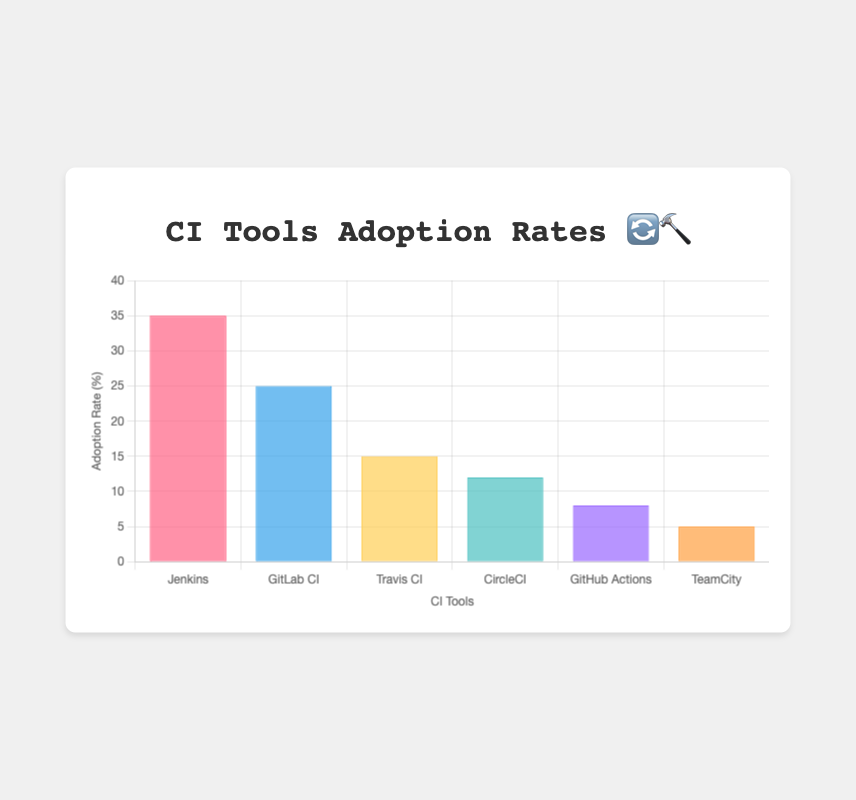What are the adoption rates for Jenkins and GitHub Actions? Jenkins has an adoption rate of 35% and GitHub Actions has an adoption rate of 8%. You can see this by looking at the height of the bars for these tools on the y-axis labeled "Adoption Rate (%)".
Answer: Jenkins: 35%, GitHub Actions: 8% What’s the title of the chart? The title is located at the top of the chart in bold text. It reads "CI Tools Adoption Rates 🔄🔨", which indicates that the chart visualizes the adoption rates of continuous integration tools with emojis representing team sizes.
Answer: CI Tools Adoption Rates 🔄🔨 Which CI tool has the lowest adoption rate? The lowest bar on the chart represents the CI tool with the lowest adoption rate. The bar for TeamCity is the shortest, indicating it has the lowest adoption rate of 5%.
Answer: TeamCity How many team size emojis are used to represent GitLab CI and CircleCI combined? GitLab CI is represented with two team size emojis (👥👥), and CircleCI is represented with one team size emoji (👥). Adding these, the total number of team size emojis is 3.
Answer: 3 Compare the adoption rates of Travis CI and CircleCI. Which one is higher and by how much? Travis CI has an adoption rate of 15%, while CircleCI has an adoption rate of 12%. To find the difference, subtract 12 from 15, which gives 3%. Therefore, Travis CI has a 3% higher adoption rate than CircleCI.
Answer: Travis CI by 3% What is the sum of the adoption rates for all the tools shown in the chart? Adding all the adoption rates together: 35 (Jenkins) + 25 (GitLab CI) + 15 (Travis CI) + 12 (CircleCI) + 8 (GitHub Actions) + 5 (TeamCity) = 100%.
Answer: 100% What is the most common team size emoji shown in the chart? By counting each team size emoji: 👥 appears in GitLab CI, CircleCI, and TeamCity, making it the most common emoji used. There are four occurrences of 👥 across the chart.
Answer: 👥 Which tool, represented by a single person emoji (👤), has the higher adoption rate? Travis CI and GitHub Actions are both indicated with the single-person emoji (👤). Travis CI has an adoption rate of 15%, while GitHub Actions has 8%. Thus, Travis CI has the higher adoption rate.
Answer: Travis CI How does the adoption rate of TeamCity compare to the combined rate of the two tools with a single-person emoji (👤)? TeamCity has an adoption rate of 5%. The combined adoption rate of Travis CI (15%) and GitHub Actions (8%) is 23%. Comparing 5% with 23%, the combined rate of the two single-person emoji tools is significantly higher.
Answer: TeamCity: 5%, Combined (Travis CI & GitHub Actions): 23% 